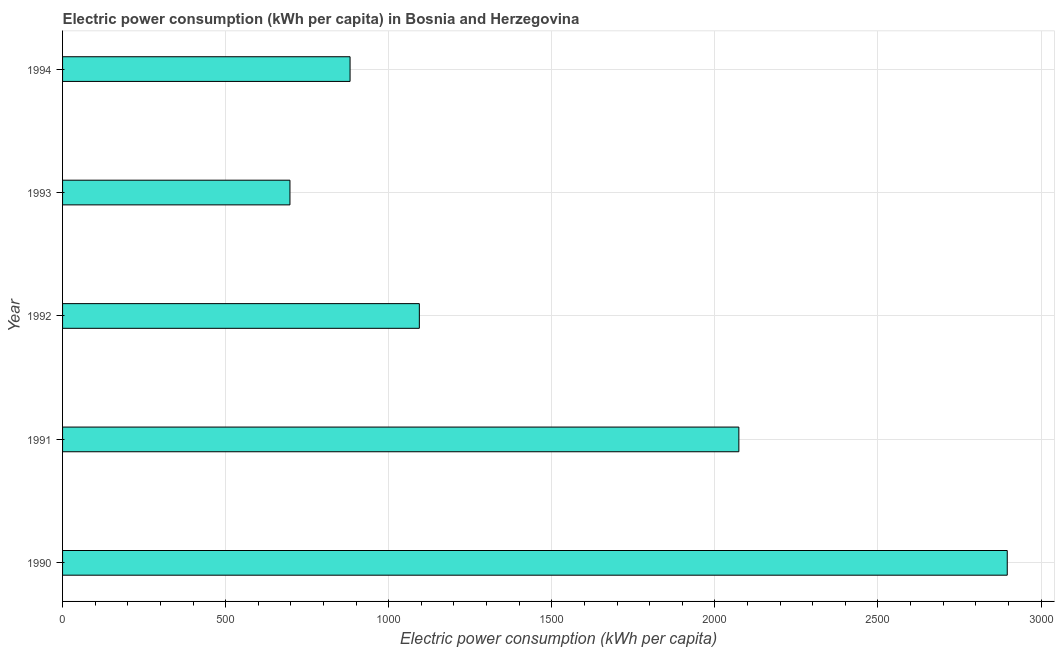Does the graph contain any zero values?
Ensure brevity in your answer.  No. Does the graph contain grids?
Your answer should be compact. Yes. What is the title of the graph?
Ensure brevity in your answer.  Electric power consumption (kWh per capita) in Bosnia and Herzegovina. What is the label or title of the X-axis?
Give a very brief answer. Electric power consumption (kWh per capita). What is the electric power consumption in 1990?
Provide a short and direct response. 2896.4. Across all years, what is the maximum electric power consumption?
Offer a very short reply. 2896.4. Across all years, what is the minimum electric power consumption?
Provide a short and direct response. 697.15. In which year was the electric power consumption maximum?
Provide a succinct answer. 1990. What is the sum of the electric power consumption?
Give a very brief answer. 7642.4. What is the difference between the electric power consumption in 1990 and 1993?
Your response must be concise. 2199.26. What is the average electric power consumption per year?
Keep it short and to the point. 1528.48. What is the median electric power consumption?
Give a very brief answer. 1093.89. What is the ratio of the electric power consumption in 1992 to that in 1994?
Make the answer very short. 1.24. Is the electric power consumption in 1991 less than that in 1993?
Your answer should be very brief. No. What is the difference between the highest and the second highest electric power consumption?
Your answer should be very brief. 822.9. What is the difference between the highest and the lowest electric power consumption?
Offer a very short reply. 2199.26. How many bars are there?
Give a very brief answer. 5. What is the difference between two consecutive major ticks on the X-axis?
Give a very brief answer. 500. Are the values on the major ticks of X-axis written in scientific E-notation?
Provide a succinct answer. No. What is the Electric power consumption (kWh per capita) of 1990?
Your response must be concise. 2896.4. What is the Electric power consumption (kWh per capita) of 1991?
Make the answer very short. 2073.5. What is the Electric power consumption (kWh per capita) in 1992?
Offer a terse response. 1093.89. What is the Electric power consumption (kWh per capita) of 1993?
Keep it short and to the point. 697.15. What is the Electric power consumption (kWh per capita) in 1994?
Ensure brevity in your answer.  881.46. What is the difference between the Electric power consumption (kWh per capita) in 1990 and 1991?
Give a very brief answer. 822.9. What is the difference between the Electric power consumption (kWh per capita) in 1990 and 1992?
Give a very brief answer. 1802.51. What is the difference between the Electric power consumption (kWh per capita) in 1990 and 1993?
Your answer should be very brief. 2199.26. What is the difference between the Electric power consumption (kWh per capita) in 1990 and 1994?
Ensure brevity in your answer.  2014.95. What is the difference between the Electric power consumption (kWh per capita) in 1991 and 1992?
Your answer should be very brief. 979.62. What is the difference between the Electric power consumption (kWh per capita) in 1991 and 1993?
Offer a terse response. 1376.36. What is the difference between the Electric power consumption (kWh per capita) in 1991 and 1994?
Provide a succinct answer. 1192.05. What is the difference between the Electric power consumption (kWh per capita) in 1992 and 1993?
Provide a succinct answer. 396.74. What is the difference between the Electric power consumption (kWh per capita) in 1992 and 1994?
Your answer should be compact. 212.43. What is the difference between the Electric power consumption (kWh per capita) in 1993 and 1994?
Your response must be concise. -184.31. What is the ratio of the Electric power consumption (kWh per capita) in 1990 to that in 1991?
Keep it short and to the point. 1.4. What is the ratio of the Electric power consumption (kWh per capita) in 1990 to that in 1992?
Make the answer very short. 2.65. What is the ratio of the Electric power consumption (kWh per capita) in 1990 to that in 1993?
Give a very brief answer. 4.16. What is the ratio of the Electric power consumption (kWh per capita) in 1990 to that in 1994?
Offer a very short reply. 3.29. What is the ratio of the Electric power consumption (kWh per capita) in 1991 to that in 1992?
Keep it short and to the point. 1.9. What is the ratio of the Electric power consumption (kWh per capita) in 1991 to that in 1993?
Ensure brevity in your answer.  2.97. What is the ratio of the Electric power consumption (kWh per capita) in 1991 to that in 1994?
Give a very brief answer. 2.35. What is the ratio of the Electric power consumption (kWh per capita) in 1992 to that in 1993?
Give a very brief answer. 1.57. What is the ratio of the Electric power consumption (kWh per capita) in 1992 to that in 1994?
Make the answer very short. 1.24. What is the ratio of the Electric power consumption (kWh per capita) in 1993 to that in 1994?
Provide a succinct answer. 0.79. 